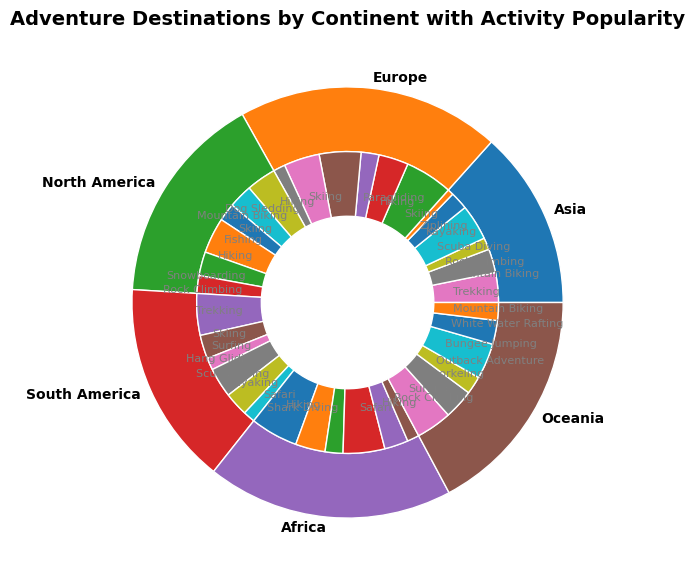Which continent has the most popular activity for trekking? The outer ring shows the continents, and the inner ring shows the activities. We can look at the segments labeled "Trekking" in each continent. The continent with the largest "Trekking" segment is Asia.
Answer: Asia What is the second most popular activity in South America? First, identify the inner ring segments within South America. The largest segment (most popular) is Trekking (Chile, 35%). The second largest segment is Hang Gliding (Brazil, 25%).
Answer: Hang Gliding Compare the popularity of rock climbing in Asia and North America. Which continent has a higher percentage? Locate the inner ring segments labeled "Rock Climbing" in both Asia and North America. Asia (Nepal) has a segment of 10%, and North America (USA) also has a segment of 15%. So, North America has a higher percentage.
Answer: North America Which activity in Europe has the smallest participation percentage? Look at the inner ring segments within Europe. The activities are Skiing, Hiking, Paragliding, and Dog Sledding. Dog Sledding (Norway) has the smallest segment at 10%.
Answer: Dog Sledding If you combine the popularity percentages of skiing in Europe and South America, what is the total percentage? First, find the skiing percentages: Europe (Switzerland, Norway) 40% + 35%, South America (Chile) 20%. Adding them: 40% + 35% + 20% = 95%.
Answer: 95% Which continent has the highest total percentage for water-related activities such as scuba diving, surfing, snorkeling, and kayaking? Look at the inner ring segments related to water activities within each continent. Calculate the total percentage for each continent. Asia (Scuba Diving, Kayaking, Thailand) = 30% + 15% = 45%, Oceania (Surfing, Snorkeling, Australia; White Water Rafting, New Zealand) = 30% + 25% + 20% = 75%, among others. Oceania has the highest total.
Answer: Oceania What is the most popular activity in Oceania based on the figure? Locate the inner ring segments within Oceania. The largest segment is Surfing (Australia) at 30%.
Answer: Surfing Compare the popularity of mountain biking in Nepal and New Zealand. Which destination has a higher percentage? Look at the segments labeled "Mountain Biking" in Nepal (Asia, 20%) and New Zealand (Oceania, 15%). Nepal has a higher percentage.
Answer: Nepal Which continent has the smallest outer ring segment? The outer ring segments represent each continent. Look for the smallest segment visually. The smallest outer ring segment belongs to Oceania.
Answer: Oceania What is the total percentage of hiking-related activities in Africa? Find and sum the segments labeled "Hiking" in Africa (South Africa and Kenya). Hiking (South Africa) = 25%, Hiking (Kenya) = 20%. Total = 25% + 20% = 45%.
Answer: 45% 